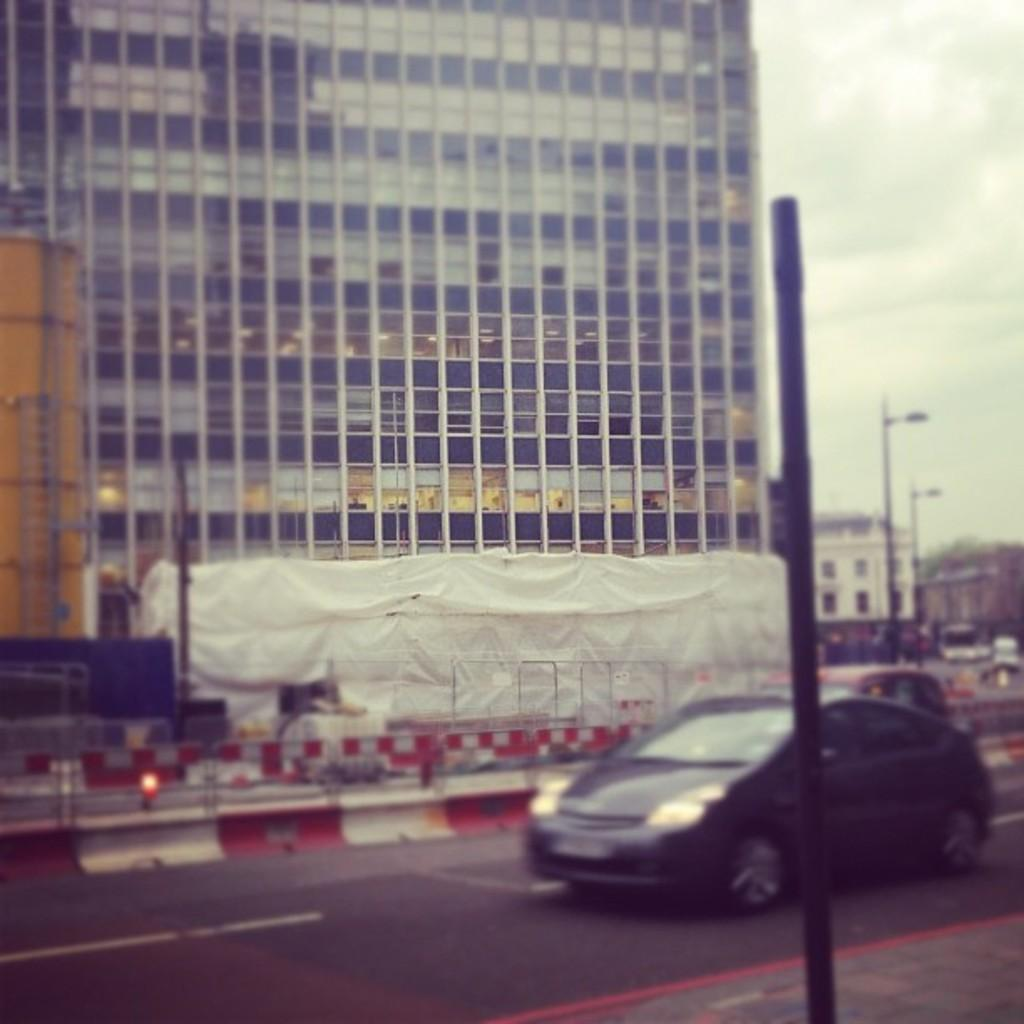What can be seen on the road in the image? There are vehicles on the road in the image. What objects are present in the image besides the vehicles? There are poles and buildings in the image. What objects are on a smaller scale in the image? There are glasses in the image. What is visible in the background of the image? The sky is visible in the background of the image. How many ladybugs can be seen on the poles in the image? There are no ladybugs present in the image; only vehicles, poles, buildings, glasses, and the sky are visible. What year is depicted in the image? The image does not depict a specific year; it is a general scene of vehicles, poles, buildings, glasses, and the sky. 